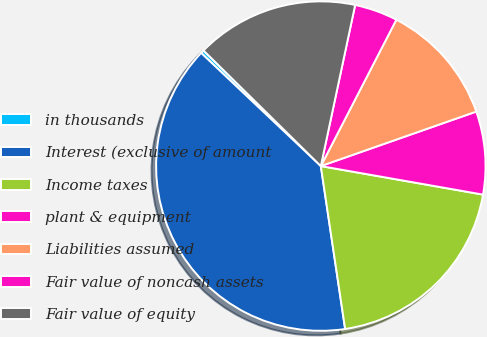Convert chart. <chart><loc_0><loc_0><loc_500><loc_500><pie_chart><fcel>in thousands<fcel>Interest (exclusive of amount<fcel>Income taxes<fcel>plant & equipment<fcel>Liabilities assumed<fcel>Fair value of noncash assets<fcel>Fair value of equity<nl><fcel>0.33%<fcel>39.41%<fcel>19.87%<fcel>8.14%<fcel>12.05%<fcel>4.24%<fcel>15.96%<nl></chart> 